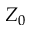Convert formula to latex. <formula><loc_0><loc_0><loc_500><loc_500>Z _ { 0 }</formula> 